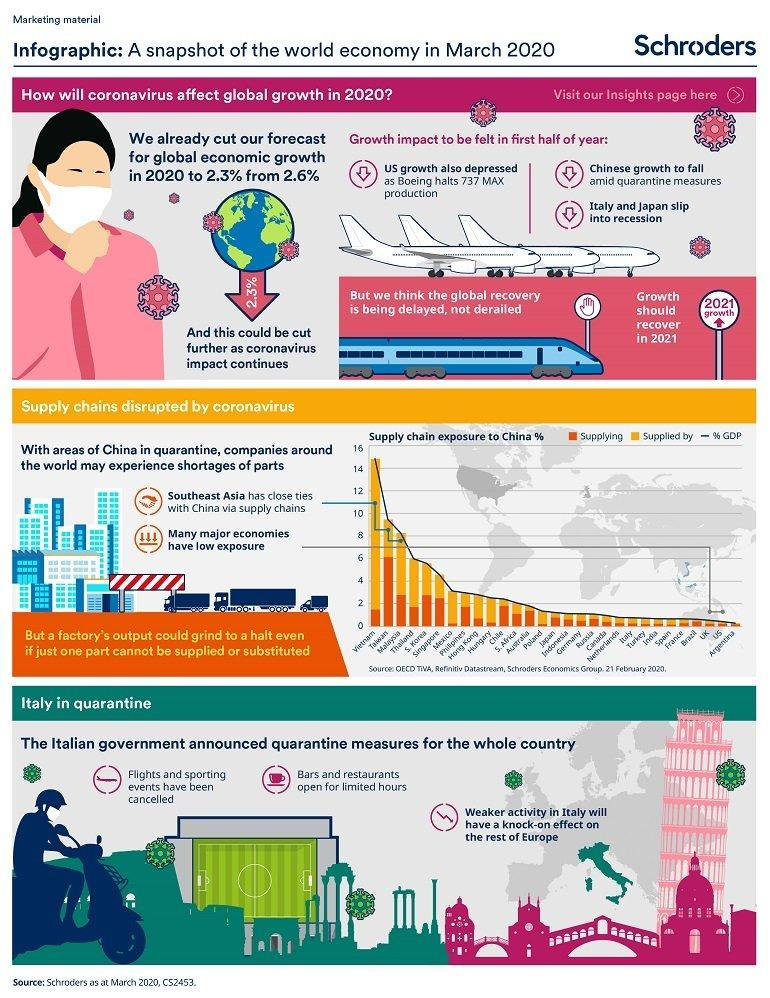How many points are under the heading "Italy in quarantine"?
Answer the question with a short phrase. 3 